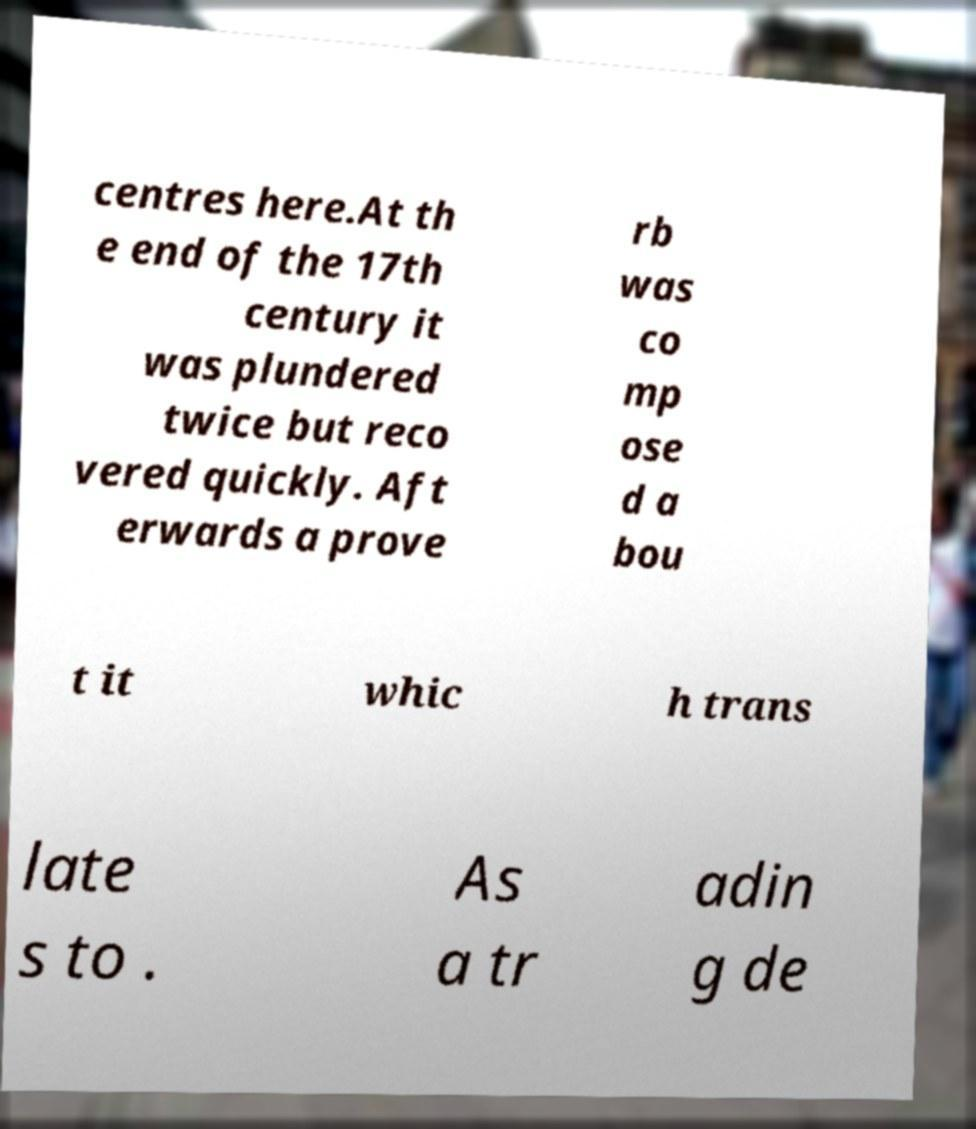There's text embedded in this image that I need extracted. Can you transcribe it verbatim? centres here.At th e end of the 17th century it was plundered twice but reco vered quickly. Aft erwards a prove rb was co mp ose d a bou t it whic h trans late s to . As a tr adin g de 